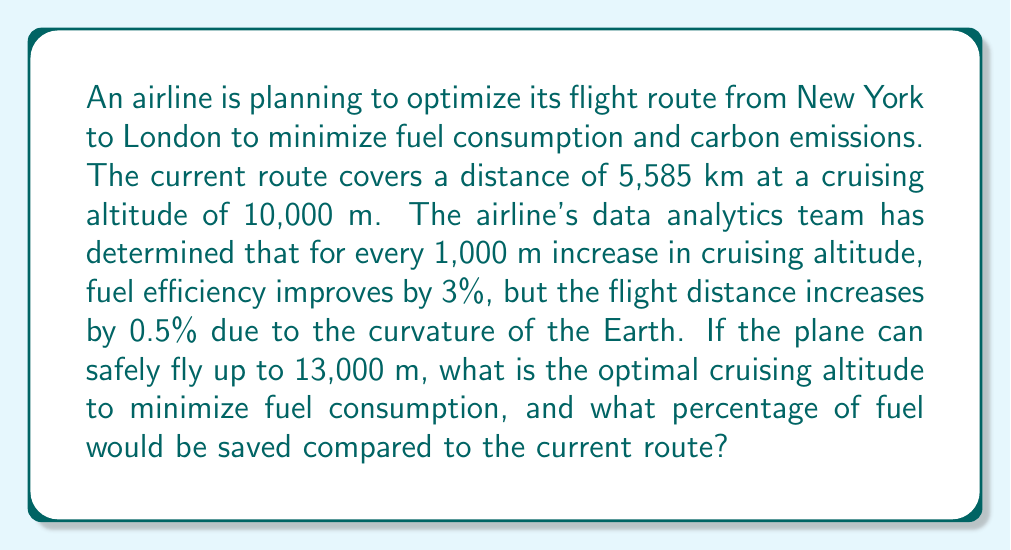Help me with this question. Let's approach this problem step-by-step:

1) First, let's define variables:
   $h$ = increase in altitude (in thousands of meters)
   $d$ = new distance
   $f$ = fuel consumption factor

2) We can express $d$ and $f$ in terms of $h$:
   $d = 5585 \cdot (1 + 0.005h)$
   $f = (1 - 0.03h)$

3) The total fuel consumption is proportional to $d \cdot f$. We want to minimize this product:

   $F(h) = d \cdot f = 5585 \cdot (1 + 0.005h) \cdot (1 - 0.03h)$

4) Expanding this expression:
   
   $F(h) = 5585 \cdot (1 + 0.005h - 0.03h - 0.00015h^2)$
   $F(h) = 5585 \cdot (1 - 0.025h - 0.00015h^2)$

5) To find the minimum, we differentiate and set to zero:

   $F'(h) = 5585 \cdot (-0.025 - 0.0003h) = 0$
   $-0.025 - 0.0003h = 0$
   $h = -0.025 / 0.0003 = 83.33$

6) This gives us the optimal increase in altitude: 8,333 m

7) The optimal cruising altitude is therefore 10,000 + 8,333 = 18,333 m

   However, the plane can only fly up to 13,000 m, so we use this as our optimal altitude.

8) The increase in altitude is thus 3,000 m, or $h = 3$

9) To calculate fuel savings, we plug this back into our fuel consumption factor:

   $f = (1 - 0.03 \cdot 3) = 0.91$

10) This means fuel consumption is 91% of the original, or a 9% saving.
Answer: The optimal cruising altitude is 13,000 m (the maximum allowed), and this would save approximately 9% in fuel consumption compared to the current route. 